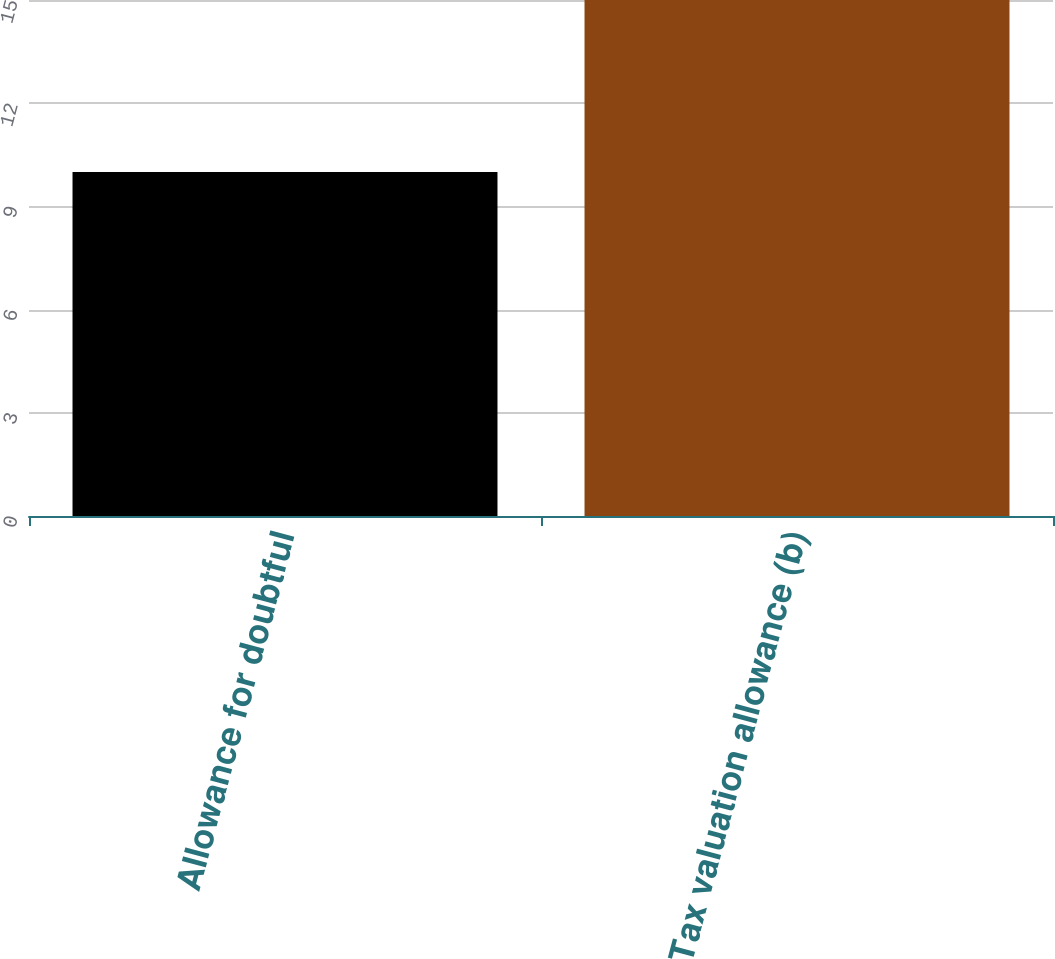<chart> <loc_0><loc_0><loc_500><loc_500><bar_chart><fcel>Allowance for doubtful<fcel>Tax valuation allowance (b)<nl><fcel>10<fcel>15<nl></chart> 